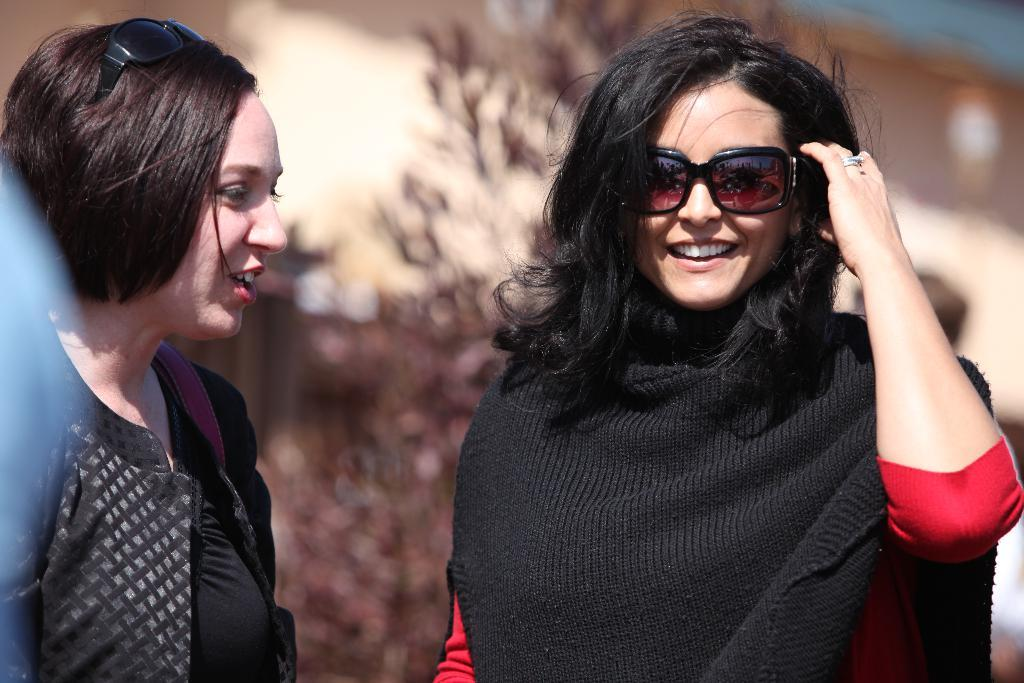How many women are in the image? There are two women in the foreground of the image. What are the women wearing? One woman is wearing a black jacket, and the other woman is wearing a black sweater. Can you describe the background of the image? The background of the image is blurred. What type of treatment is being administered to the women in the image? There is no indication in the image that the women are receiving any treatment. 